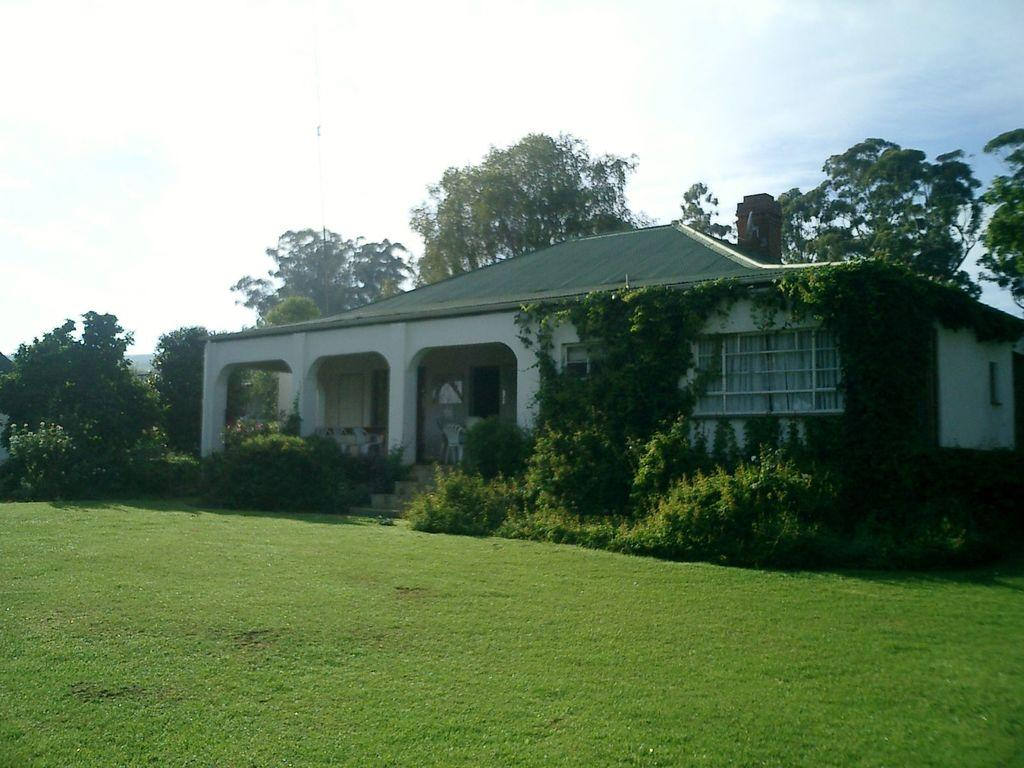What type of structure is visible in the image? There is a house in the image. What is the color of the grass in the image? The grass in the image is green. What other types of vegetation can be seen in the image? There are plants in the image. What is visible in the background of the image? There are trees in the background of the image. What is the condition of the sky in the image? The sky is clear in the image. What type of brush is being used to paint the crown in the image? There is no brush or crown present in the image. What is the profit margin of the plants in the image? There is no mention of profit in the image, as it is focused on the visual elements of the scene. 